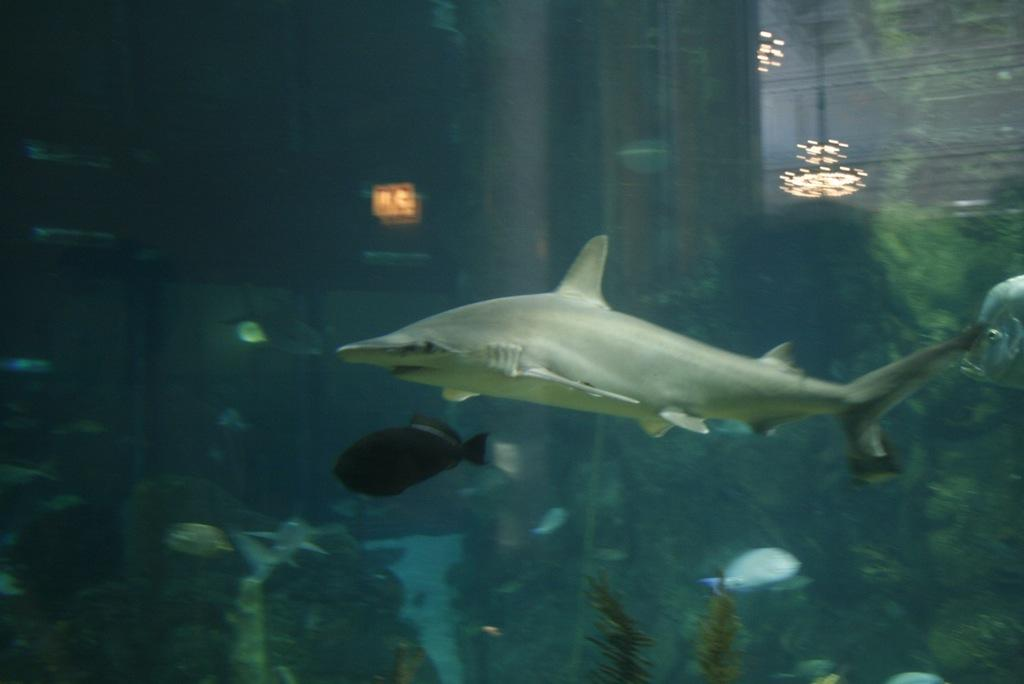What type of animal is the main subject of the image? There is a shark in the image. What other creatures can be seen in the image? There are fishes in the image. What environment is depicted in the image? The image depicts an underwater environment. What statement does the shark make in the image? The shark does not make any statements in the image, as it is an animal and cannot speak. 